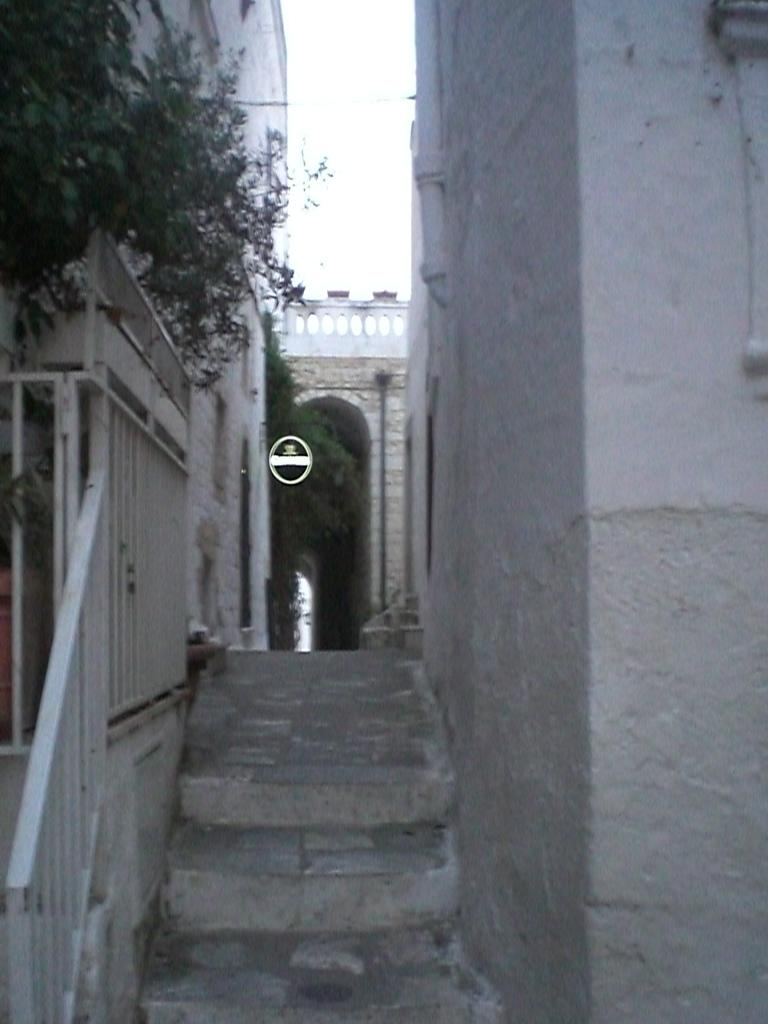What architectural feature is present in the image? There are steps in the image. What is the purpose of the barrier in the image? There is a fence in the image, which serves as a barrier. What type of vegetation is on the left side of the image? There are plants on the left side of the image. What can be seen in the background of the image? There is a building, plants, a wall, a board, and the sky visible in the background of the image. What type of flame can be seen in the image? There is no flame present in the image. --- Facts: 1. There is a person in the image. 12. The person is wearing a hat. 13. The person is holding a book. 14. There is a table in the image. 15. The table has a vase with flowers on it. 16. There is a window in the background of the image. 17. The window has curtains on it. 18. There is a painting on the wall in the background of the image. Absurd Topics: unicorn, rainbow, ocean Conversation: What is the main subject in the image? There is a person in the image. What is the person wearing in the image? The person is wearing a hat in the image. What is the person holding in the image? The person is holding a book in the image. What is on the table in the image? There is a vase with flowers on the table in the image. What can be seen in the background of the image? There is a window with curtains on it, and a painting on the wall in the background of the image. Reasoning: Let's think step by step in order to produce the conversation. We start by identifying the main subject in the image, which is the person. Then, we describe the person's attire, mentioning the hat. Next, we focus on the object the person is holding, which is a book. After that, we describe the table and its contents, which is a vase with flowers on it. Finally, we describe the background of the image, mentioning the window with curtains on it, and the painting on the wall. Absurd Question/Answer: Can you see a unicorn in the image? There is no unicorn present in the image. --- Facts: 11. There is a dog in the image. 12. The dog is sitting on a chair. 13. The dog is wearing a bow tie. 14. There is a person in the image. 15. The person is petting the dog. 16. There is a fireplace in the background of the image. 17. There is a rug in front of the fireplace. 18. There is 